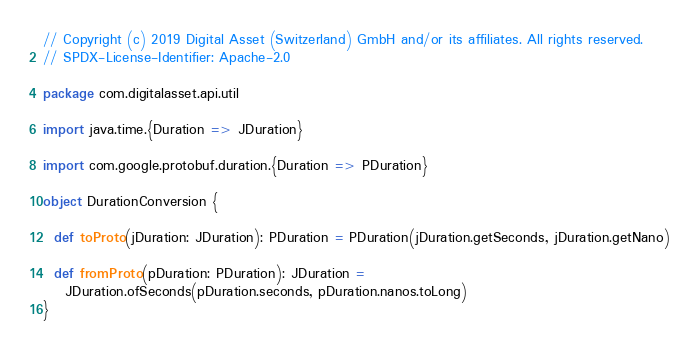Convert code to text. <code><loc_0><loc_0><loc_500><loc_500><_Scala_>// Copyright (c) 2019 Digital Asset (Switzerland) GmbH and/or its affiliates. All rights reserved.
// SPDX-License-Identifier: Apache-2.0

package com.digitalasset.api.util

import java.time.{Duration => JDuration}

import com.google.protobuf.duration.{Duration => PDuration}

object DurationConversion {

  def toProto(jDuration: JDuration): PDuration = PDuration(jDuration.getSeconds, jDuration.getNano)

  def fromProto(pDuration: PDuration): JDuration =
    JDuration.ofSeconds(pDuration.seconds, pDuration.nanos.toLong)
}
</code> 